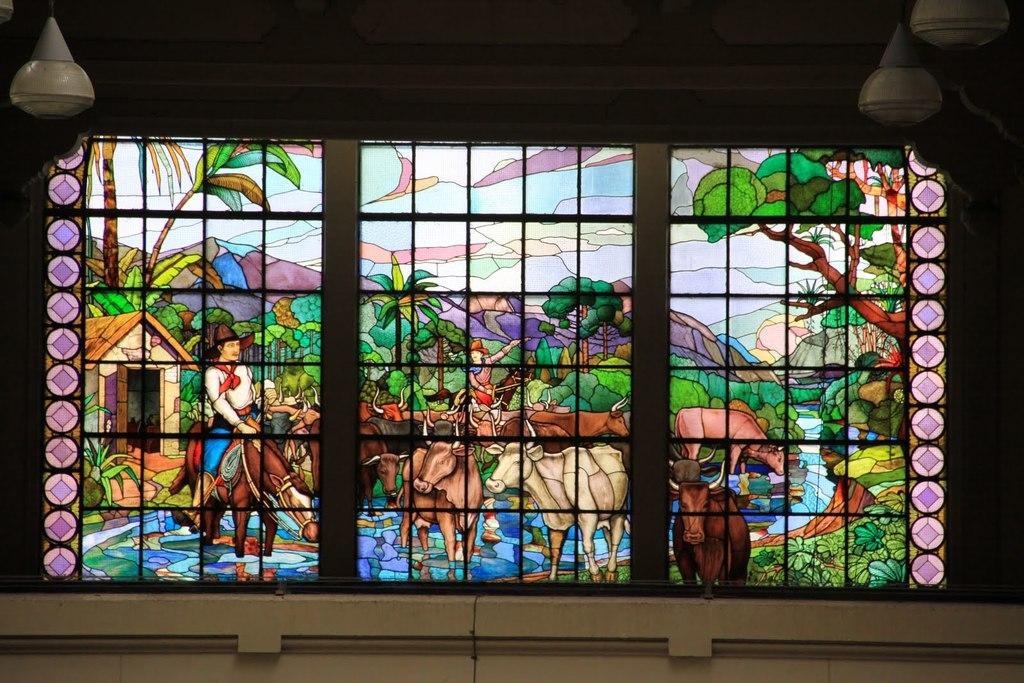What type of window is depicted in the image? There is a stained glass window window in the image. What part of a room or building can be seen in the image? There is a ceiling visible in the image. What is located at the bottom of the image? There is an object at the bottom of the image. What organization is responsible for the direction of the fifth object in the image? There is no organization mentioned in the image, and there is no indication of the number of objects or a specific direction for any object. 